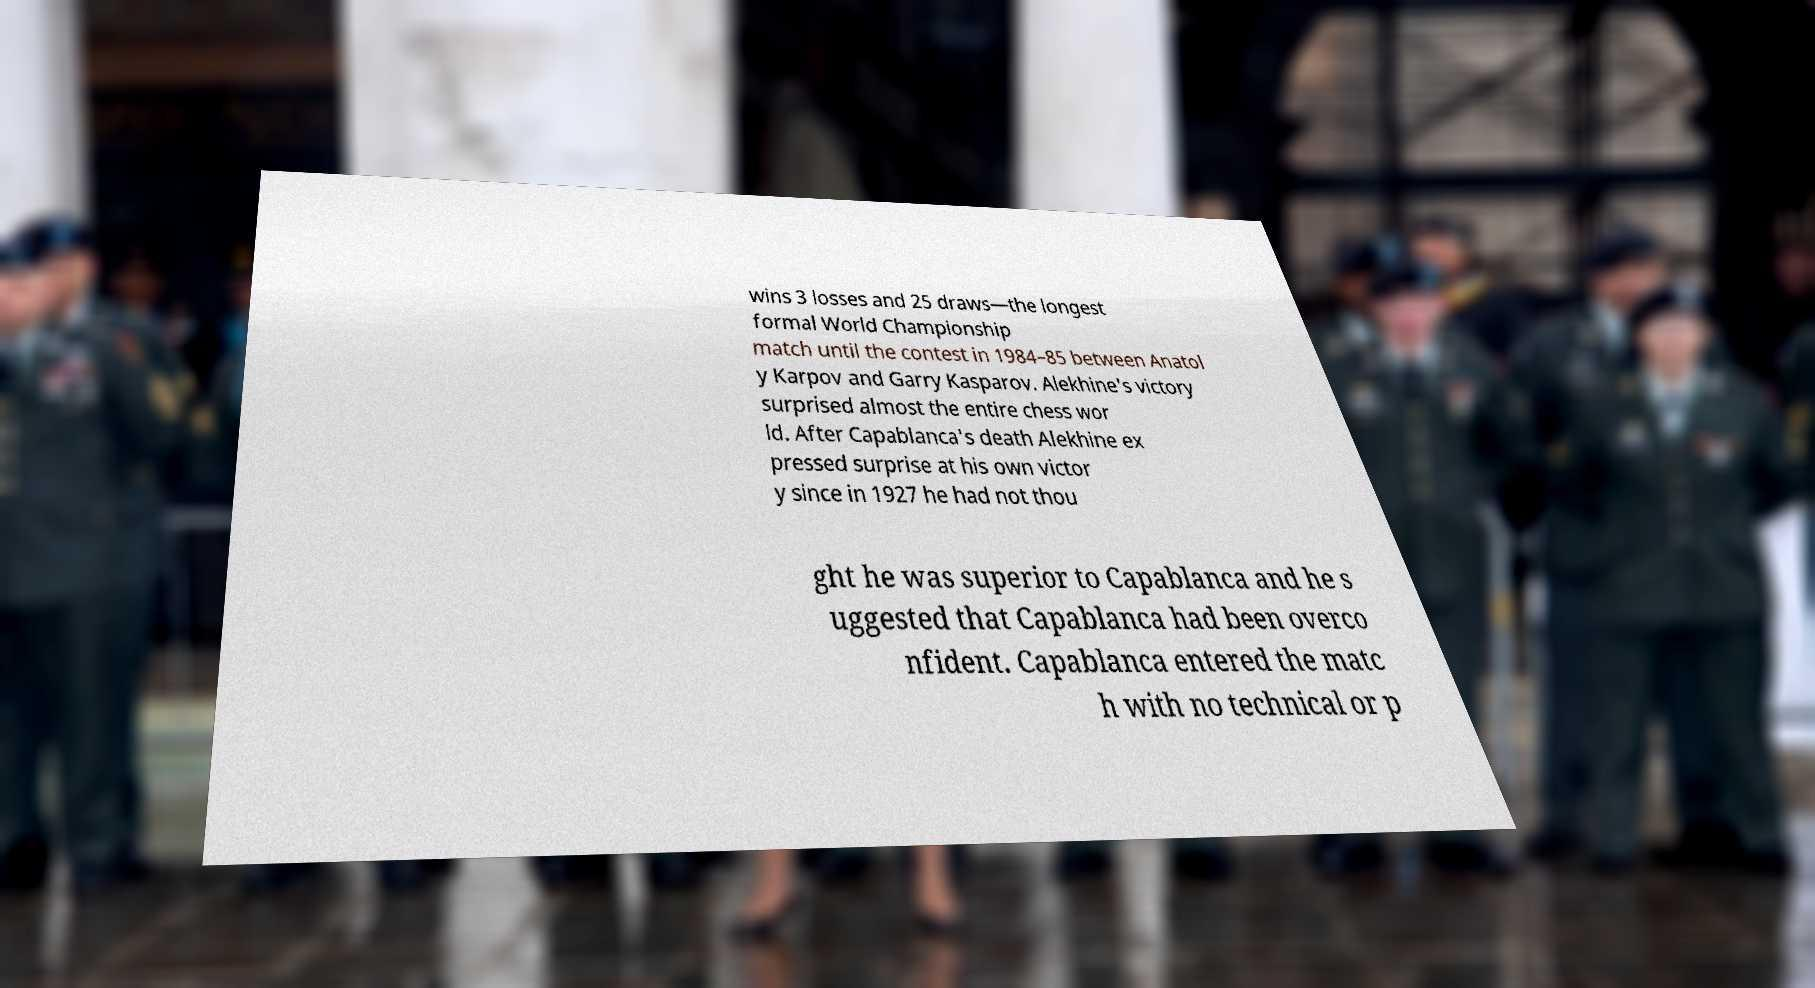What messages or text are displayed in this image? I need them in a readable, typed format. wins 3 losses and 25 draws—the longest formal World Championship match until the contest in 1984–85 between Anatol y Karpov and Garry Kasparov. Alekhine's victory surprised almost the entire chess wor ld. After Capablanca's death Alekhine ex pressed surprise at his own victor y since in 1927 he had not thou ght he was superior to Capablanca and he s uggested that Capablanca had been overco nfident. Capablanca entered the matc h with no technical or p 